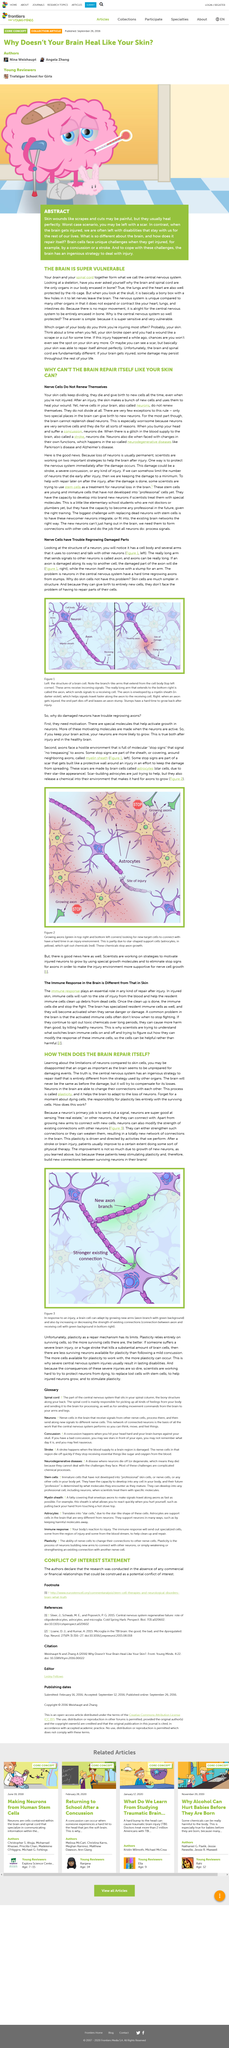List a handful of essential elements in this visual. The brain appears to be unprepared for damaging events. It is acceptable for the central nervous system to be entirely encased in bone because there is minimal movement required for its proper function. It is often painful, yet it heals perfectly in the end. Skin wounds such as scrapes and cuts are an example of this. The brain and the spinal cord collectively constitute the central nervous system. Plasticity, a remarkable ability of the brain to adapt and change in response to experience and injury, plays a crucial role in helping the brain to adapt to the loss of neurons, thereby promoting recovery and regeneration. 